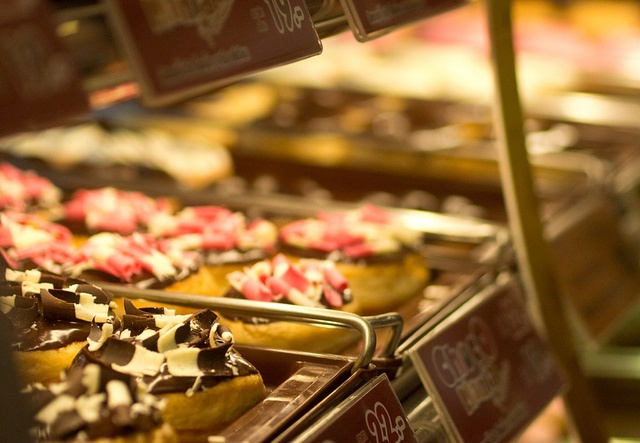Describe the objects in this image and their specific colors. I can see cake in maroon, olive, black, and khaki tones, donut in maroon, black, and olive tones, donut in maroon, olive, orange, and tan tones, cake in maroon, olive, black, and khaki tones, and cake in maroon, tan, and brown tones in this image. 